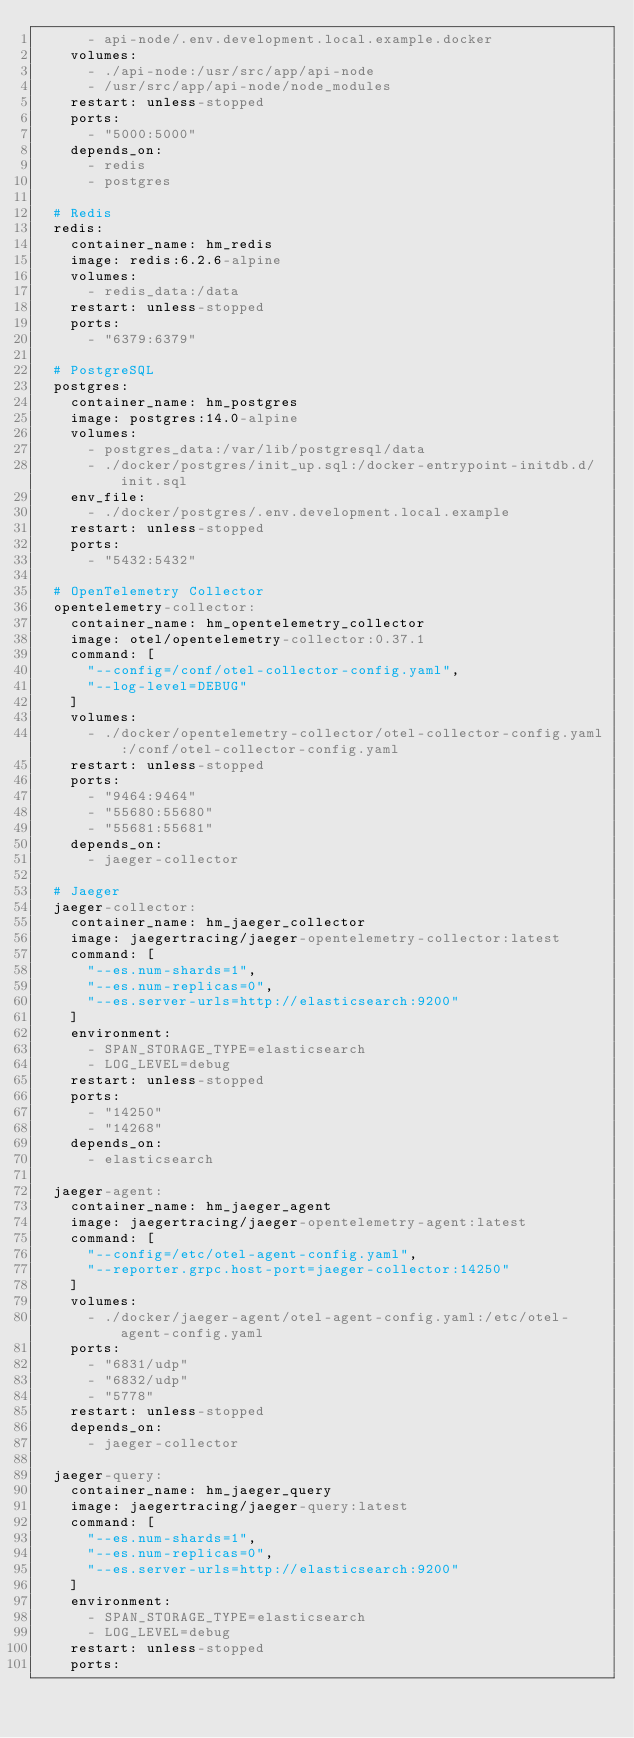Convert code to text. <code><loc_0><loc_0><loc_500><loc_500><_YAML_>      - api-node/.env.development.local.example.docker
    volumes:
      - ./api-node:/usr/src/app/api-node
      - /usr/src/app/api-node/node_modules
    restart: unless-stopped
    ports:
      - "5000:5000"
    depends_on:
      - redis
      - postgres

  # Redis
  redis:
    container_name: hm_redis
    image: redis:6.2.6-alpine
    volumes:
      - redis_data:/data
    restart: unless-stopped
    ports:
      - "6379:6379"

  # PostgreSQL
  postgres:
    container_name: hm_postgres
    image: postgres:14.0-alpine
    volumes:
      - postgres_data:/var/lib/postgresql/data
      - ./docker/postgres/init_up.sql:/docker-entrypoint-initdb.d/init.sql
    env_file:
      - ./docker/postgres/.env.development.local.example
    restart: unless-stopped
    ports:
      - "5432:5432"

  # OpenTelemetry Collector
  opentelemetry-collector:
    container_name: hm_opentelemetry_collector
    image: otel/opentelemetry-collector:0.37.1
    command: [
      "--config=/conf/otel-collector-config.yaml",
      "--log-level=DEBUG"
    ]
    volumes:
      - ./docker/opentelemetry-collector/otel-collector-config.yaml:/conf/otel-collector-config.yaml
    restart: unless-stopped
    ports:
      - "9464:9464"
      - "55680:55680"
      - "55681:55681"
    depends_on:
      - jaeger-collector

  # Jaeger
  jaeger-collector:
    container_name: hm_jaeger_collector
    image: jaegertracing/jaeger-opentelemetry-collector:latest
    command: [
      "--es.num-shards=1",
      "--es.num-replicas=0",
      "--es.server-urls=http://elasticsearch:9200"
    ]
    environment:
      - SPAN_STORAGE_TYPE=elasticsearch
      - LOG_LEVEL=debug
    restart: unless-stopped
    ports:
      - "14250"
      - "14268"
    depends_on:
      - elasticsearch

  jaeger-agent:
    container_name: hm_jaeger_agent
    image: jaegertracing/jaeger-opentelemetry-agent:latest
    command: [
      "--config=/etc/otel-agent-config.yaml",
      "--reporter.grpc.host-port=jaeger-collector:14250"
    ]
    volumes:
      - ./docker/jaeger-agent/otel-agent-config.yaml:/etc/otel-agent-config.yaml
    ports:
      - "6831/udp"
      - "6832/udp"
      - "5778"
    restart: unless-stopped
    depends_on:
      - jaeger-collector

  jaeger-query:
    container_name: hm_jaeger_query
    image: jaegertracing/jaeger-query:latest
    command: [
      "--es.num-shards=1",
      "--es.num-replicas=0",
      "--es.server-urls=http://elasticsearch:9200"
    ]
    environment:
      - SPAN_STORAGE_TYPE=elasticsearch
      - LOG_LEVEL=debug
    restart: unless-stopped
    ports:</code> 